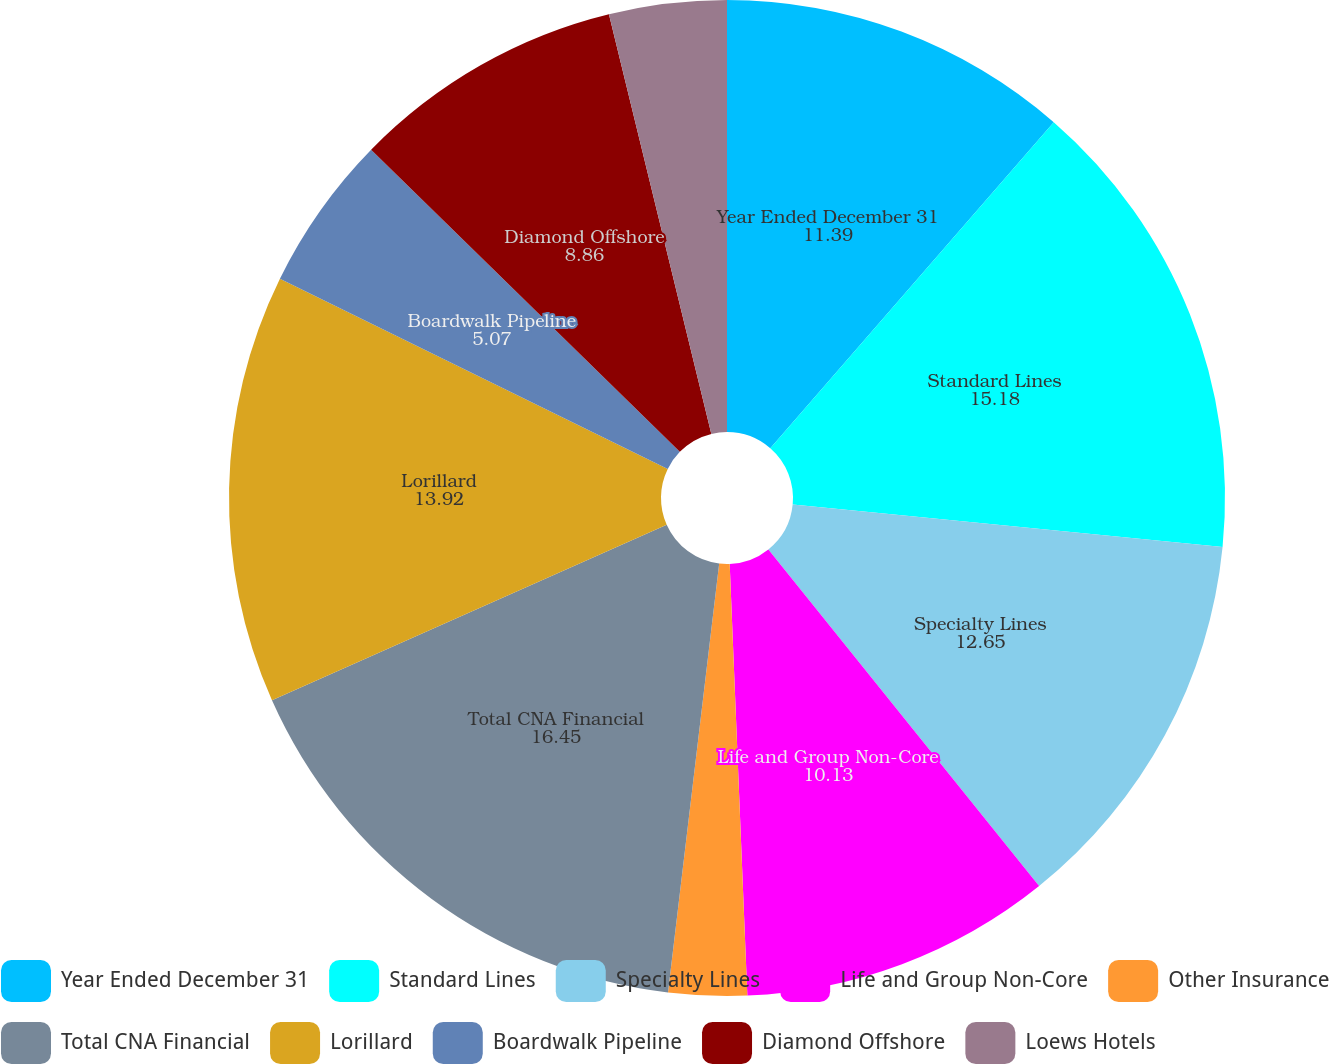Convert chart to OTSL. <chart><loc_0><loc_0><loc_500><loc_500><pie_chart><fcel>Year Ended December 31<fcel>Standard Lines<fcel>Specialty Lines<fcel>Life and Group Non-Core<fcel>Other Insurance<fcel>Total CNA Financial<fcel>Lorillard<fcel>Boardwalk Pipeline<fcel>Diamond Offshore<fcel>Loews Hotels<nl><fcel>11.39%<fcel>15.18%<fcel>12.65%<fcel>10.13%<fcel>2.54%<fcel>16.45%<fcel>13.92%<fcel>5.07%<fcel>8.86%<fcel>3.81%<nl></chart> 